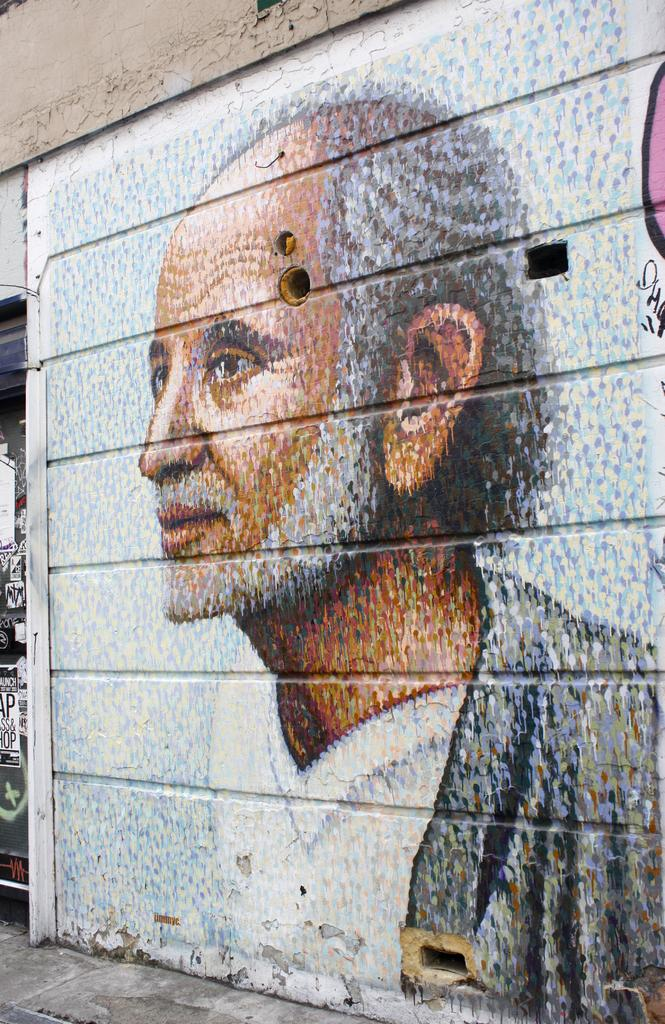What is hanging on the wall in the image? There is a painting on the wall in the image. What can be seen on the left side of the image? There are posters with text on the left side of the image. What type of pin can be seen on the back of the painting in the image? There is no pin visible on the back of the painting in the image, as the painting is hanging on the wall. What is the edge of the painting like in the image? The provided facts do not mention the edge of the painting, so we cannot answer this question definitively. 